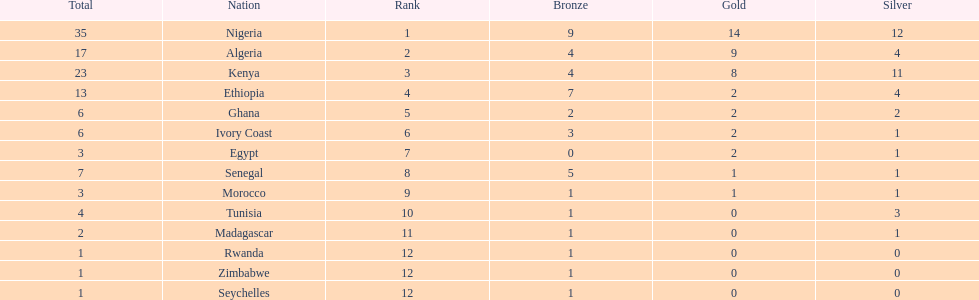Can you parse all the data within this table? {'header': ['Total', 'Nation', 'Rank', 'Bronze', 'Gold', 'Silver'], 'rows': [['35', 'Nigeria', '1', '9', '14', '12'], ['17', 'Algeria', '2', '4', '9', '4'], ['23', 'Kenya', '3', '4', '8', '11'], ['13', 'Ethiopia', '4', '7', '2', '4'], ['6', 'Ghana', '5', '2', '2', '2'], ['6', 'Ivory Coast', '6', '3', '2', '1'], ['3', 'Egypt', '7', '0', '2', '1'], ['7', 'Senegal', '8', '5', '1', '1'], ['3', 'Morocco', '9', '1', '1', '1'], ['4', 'Tunisia', '10', '1', '0', '3'], ['2', 'Madagascar', '11', '1', '0', '1'], ['1', 'Rwanda', '12', '1', '0', '0'], ['1', 'Zimbabwe', '12', '1', '0', '0'], ['1', 'Seychelles', '12', '1', '0', '0']]} Total number of bronze medals nigeria earned? 9. 